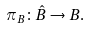Convert formula to latex. <formula><loc_0><loc_0><loc_500><loc_500>\pi _ { B } \colon \hat { B } \to B .</formula> 